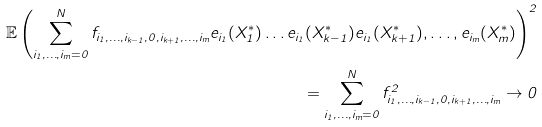Convert formula to latex. <formula><loc_0><loc_0><loc_500><loc_500>\mathbb { E } \left ( \sum _ { i _ { 1 } , \dots , i _ { m } = 0 } ^ { N } f _ { i _ { 1 } , \dots , i _ { k - 1 } , 0 , i _ { k + 1 } , \dots , i _ { m } } e _ { i _ { 1 } } ( X ^ { * } _ { 1 } ) \dots e _ { i _ { 1 } } ( X ^ { * } _ { k - 1 } ) e _ { i _ { 1 } } ( X ^ { * } _ { k + 1 } ) , \dots , e _ { i _ { m } } ( X ^ { * } _ { m } ) \right ) ^ { 2 } \\ = \sum _ { i _ { 1 } , \dots , i _ { m } = 0 } ^ { N } f _ { i _ { 1 } , \dots , i _ { k - 1 } , 0 , i _ { k + 1 } , \dots , i _ { m } } ^ { 2 } \rightarrow 0</formula> 